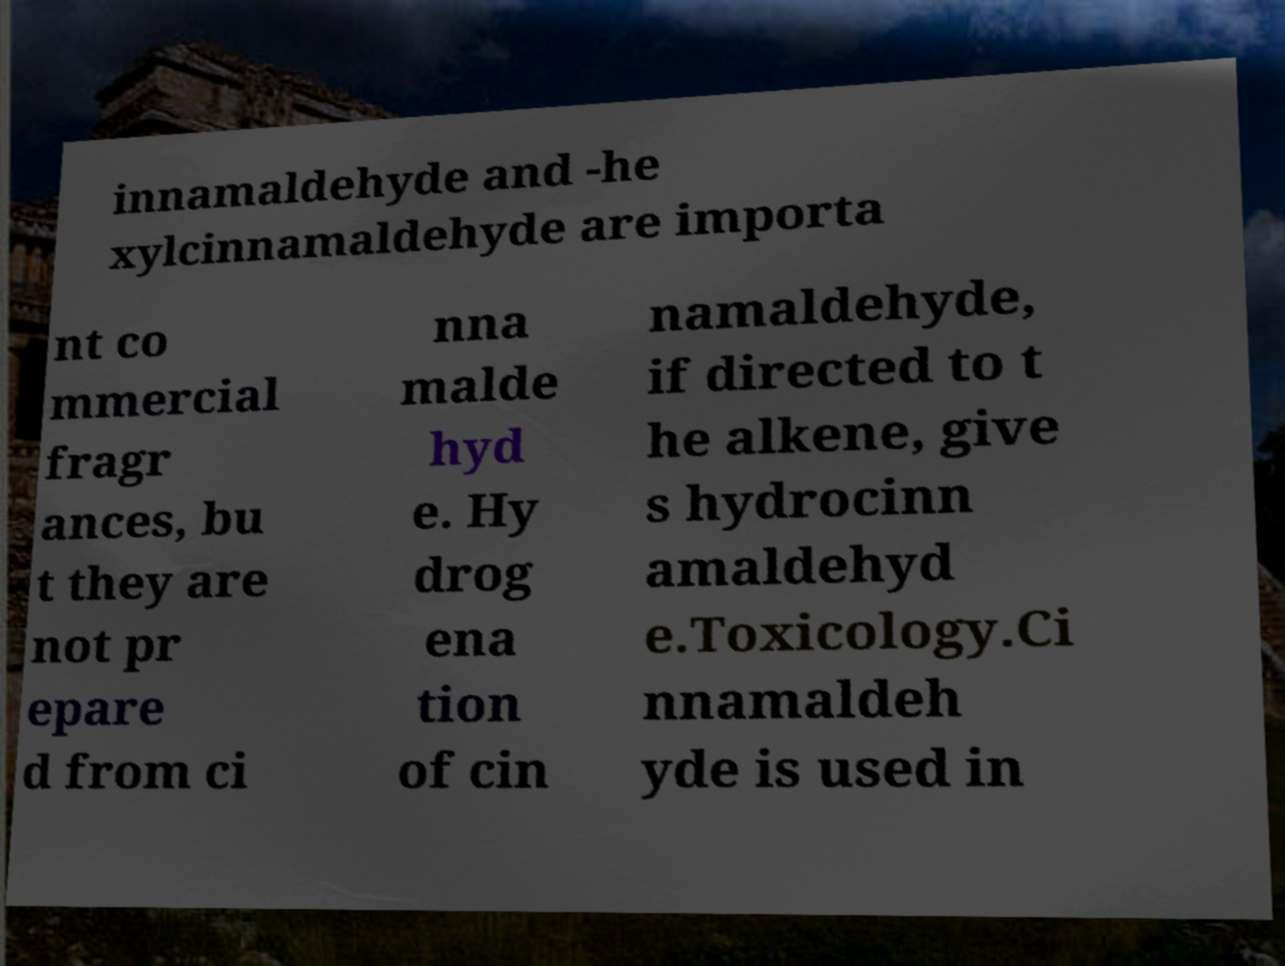Could you assist in decoding the text presented in this image and type it out clearly? innamaldehyde and -he xylcinnamaldehyde are importa nt co mmercial fragr ances, bu t they are not pr epare d from ci nna malde hyd e. Hy drog ena tion of cin namaldehyde, if directed to t he alkene, give s hydrocinn amaldehyd e.Toxicology.Ci nnamaldeh yde is used in 